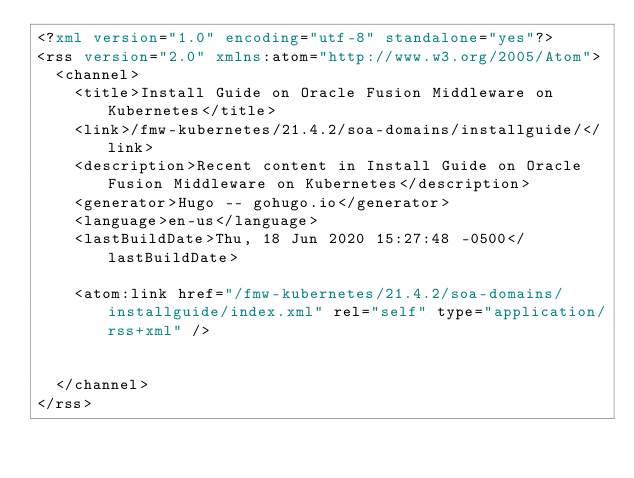Convert code to text. <code><loc_0><loc_0><loc_500><loc_500><_XML_><?xml version="1.0" encoding="utf-8" standalone="yes"?>
<rss version="2.0" xmlns:atom="http://www.w3.org/2005/Atom">
  <channel>
    <title>Install Guide on Oracle Fusion Middleware on Kubernetes</title>
    <link>/fmw-kubernetes/21.4.2/soa-domains/installguide/</link>
    <description>Recent content in Install Guide on Oracle Fusion Middleware on Kubernetes</description>
    <generator>Hugo -- gohugo.io</generator>
    <language>en-us</language>
    <lastBuildDate>Thu, 18 Jun 2020 15:27:48 -0500</lastBuildDate>
    
	<atom:link href="/fmw-kubernetes/21.4.2/soa-domains/installguide/index.xml" rel="self" type="application/rss+xml" />
    
    
  </channel>
</rss></code> 